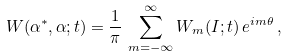Convert formula to latex. <formula><loc_0><loc_0><loc_500><loc_500>W ( \alpha ^ { * } , \alpha ; t ) = \frac { 1 } { \pi } \, \sum _ { m = - \infty } ^ { \infty } W _ { m } ( I ; t ) \, e ^ { i m \theta } \, ,</formula> 